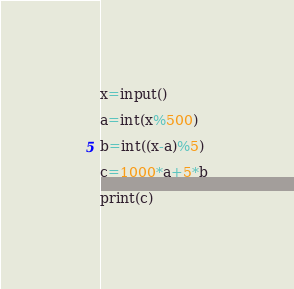<code> <loc_0><loc_0><loc_500><loc_500><_Python_>x=input()

a=int(x%500)

b=int((x-a)%5)

c=1000*a+5*b

print(c)</code> 